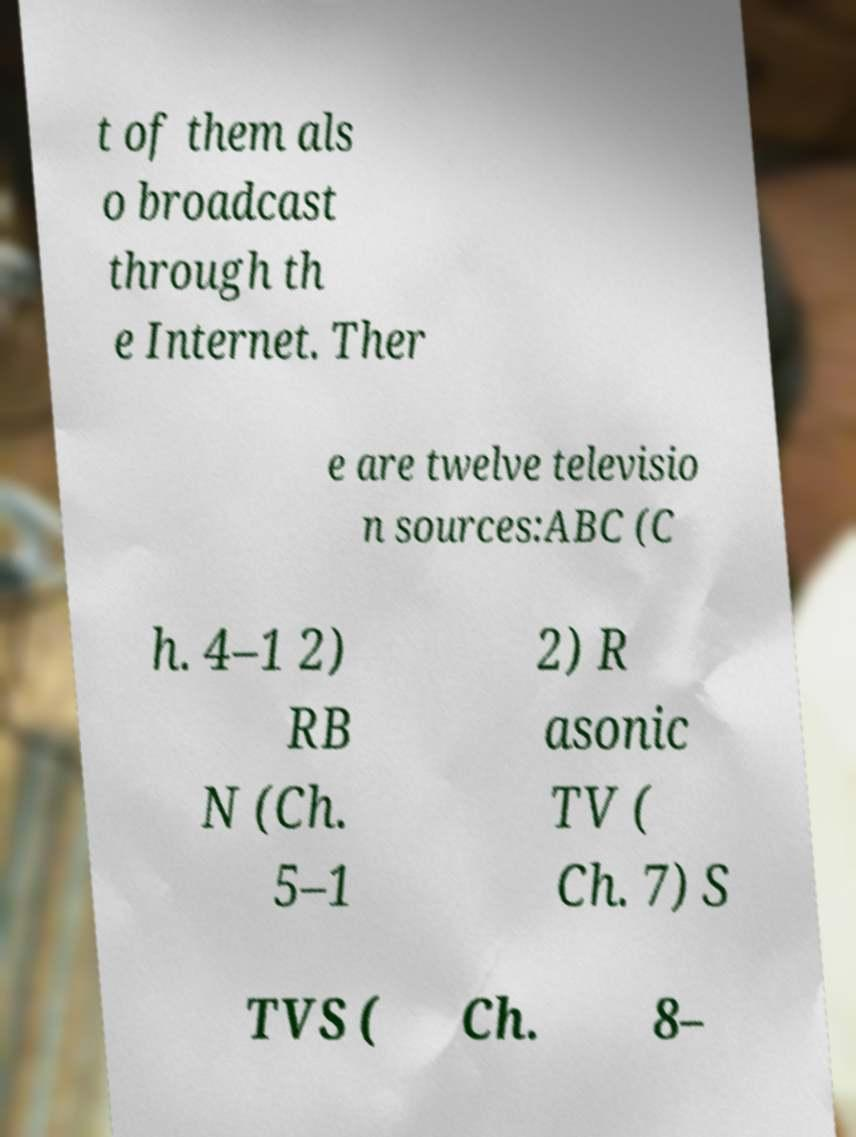Can you accurately transcribe the text from the provided image for me? t of them als o broadcast through th e Internet. Ther e are twelve televisio n sources:ABC (C h. 4–1 2) RB N (Ch. 5–1 2) R asonic TV ( Ch. 7) S TVS ( Ch. 8– 